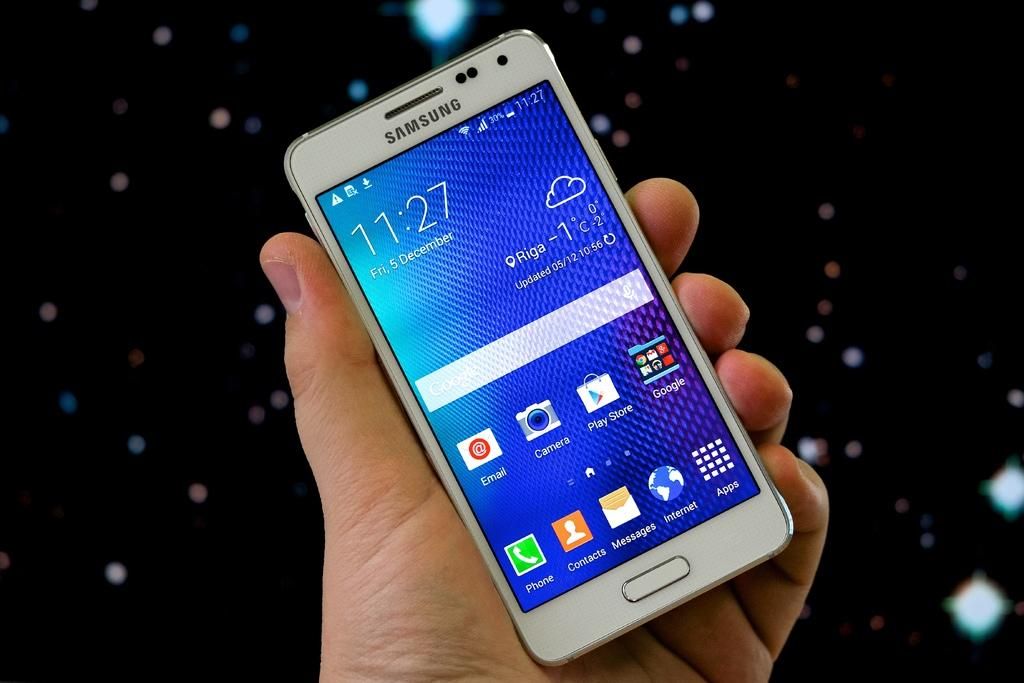<image>
Summarize the visual content of the image. Hand holding a cellphone that shows 11:27 on the screen. 